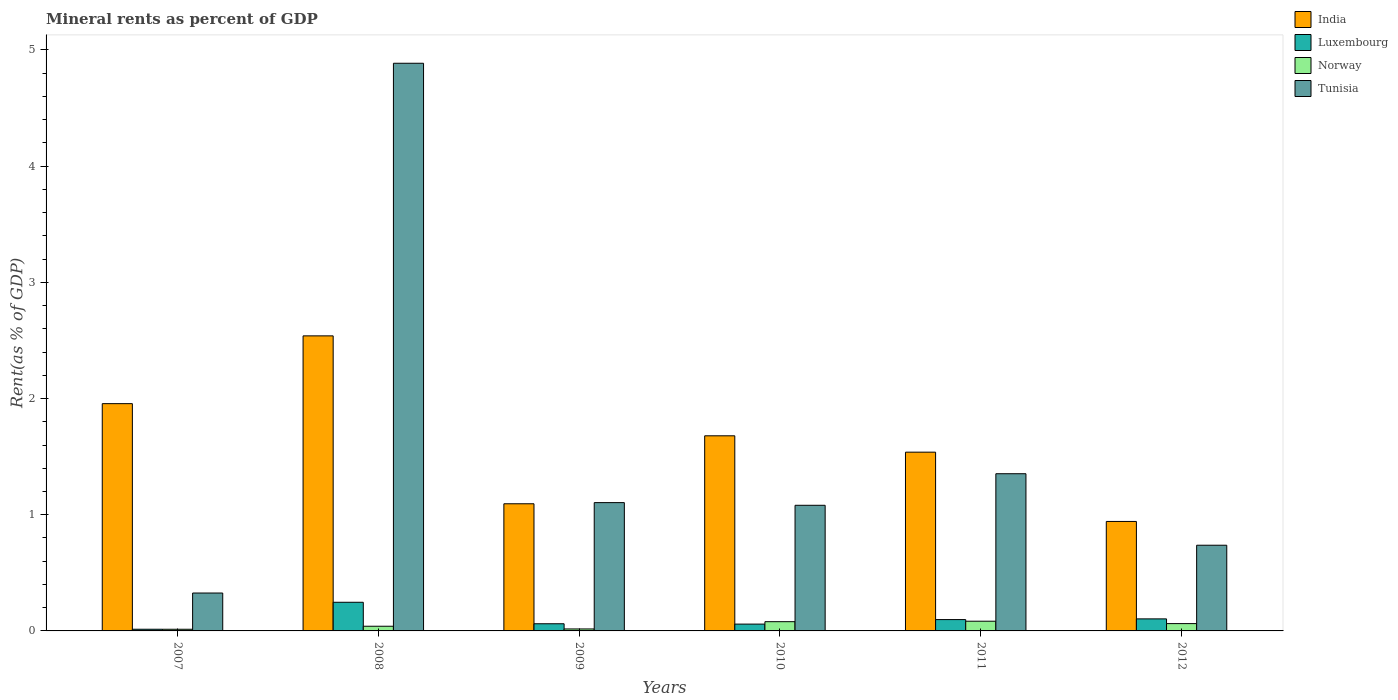How many groups of bars are there?
Provide a short and direct response. 6. Are the number of bars per tick equal to the number of legend labels?
Provide a short and direct response. Yes. Are the number of bars on each tick of the X-axis equal?
Offer a very short reply. Yes. How many bars are there on the 5th tick from the left?
Your response must be concise. 4. What is the mineral rent in India in 2009?
Ensure brevity in your answer.  1.09. Across all years, what is the maximum mineral rent in India?
Your response must be concise. 2.54. Across all years, what is the minimum mineral rent in India?
Provide a succinct answer. 0.94. In which year was the mineral rent in Luxembourg maximum?
Make the answer very short. 2008. What is the total mineral rent in Luxembourg in the graph?
Make the answer very short. 0.58. What is the difference between the mineral rent in Norway in 2007 and that in 2009?
Keep it short and to the point. -0. What is the difference between the mineral rent in Luxembourg in 2007 and the mineral rent in Norway in 2010?
Your answer should be compact. -0.07. What is the average mineral rent in Norway per year?
Provide a short and direct response. 0.05. In the year 2011, what is the difference between the mineral rent in Luxembourg and mineral rent in Tunisia?
Offer a very short reply. -1.26. In how many years, is the mineral rent in Tunisia greater than 2.8 %?
Offer a terse response. 1. What is the ratio of the mineral rent in Norway in 2008 to that in 2011?
Ensure brevity in your answer.  0.48. Is the difference between the mineral rent in Luxembourg in 2010 and 2012 greater than the difference between the mineral rent in Tunisia in 2010 and 2012?
Give a very brief answer. No. What is the difference between the highest and the second highest mineral rent in India?
Provide a short and direct response. 0.58. What is the difference between the highest and the lowest mineral rent in Luxembourg?
Offer a terse response. 0.23. In how many years, is the mineral rent in Tunisia greater than the average mineral rent in Tunisia taken over all years?
Ensure brevity in your answer.  1. Is the sum of the mineral rent in Norway in 2009 and 2012 greater than the maximum mineral rent in Luxembourg across all years?
Provide a succinct answer. No. Is it the case that in every year, the sum of the mineral rent in Tunisia and mineral rent in Norway is greater than the sum of mineral rent in India and mineral rent in Luxembourg?
Provide a succinct answer. No. What does the 1st bar from the left in 2008 represents?
Offer a terse response. India. What does the 3rd bar from the right in 2007 represents?
Give a very brief answer. Luxembourg. How many bars are there?
Provide a short and direct response. 24. What is the difference between two consecutive major ticks on the Y-axis?
Offer a terse response. 1. Are the values on the major ticks of Y-axis written in scientific E-notation?
Your answer should be very brief. No. Does the graph contain any zero values?
Provide a short and direct response. No. Does the graph contain grids?
Keep it short and to the point. No. How many legend labels are there?
Your answer should be compact. 4. What is the title of the graph?
Give a very brief answer. Mineral rents as percent of GDP. Does "American Samoa" appear as one of the legend labels in the graph?
Your response must be concise. No. What is the label or title of the Y-axis?
Keep it short and to the point. Rent(as % of GDP). What is the Rent(as % of GDP) of India in 2007?
Your response must be concise. 1.96. What is the Rent(as % of GDP) of Luxembourg in 2007?
Make the answer very short. 0.01. What is the Rent(as % of GDP) in Norway in 2007?
Keep it short and to the point. 0.01. What is the Rent(as % of GDP) in Tunisia in 2007?
Keep it short and to the point. 0.33. What is the Rent(as % of GDP) of India in 2008?
Your answer should be compact. 2.54. What is the Rent(as % of GDP) in Luxembourg in 2008?
Your answer should be compact. 0.25. What is the Rent(as % of GDP) in Norway in 2008?
Give a very brief answer. 0.04. What is the Rent(as % of GDP) of Tunisia in 2008?
Make the answer very short. 4.89. What is the Rent(as % of GDP) in India in 2009?
Provide a succinct answer. 1.09. What is the Rent(as % of GDP) of Luxembourg in 2009?
Make the answer very short. 0.06. What is the Rent(as % of GDP) in Norway in 2009?
Offer a very short reply. 0.02. What is the Rent(as % of GDP) in Tunisia in 2009?
Your answer should be very brief. 1.1. What is the Rent(as % of GDP) in India in 2010?
Your answer should be compact. 1.68. What is the Rent(as % of GDP) in Luxembourg in 2010?
Provide a short and direct response. 0.06. What is the Rent(as % of GDP) of Norway in 2010?
Your response must be concise. 0.08. What is the Rent(as % of GDP) of Tunisia in 2010?
Provide a succinct answer. 1.08. What is the Rent(as % of GDP) of India in 2011?
Your answer should be compact. 1.54. What is the Rent(as % of GDP) in Luxembourg in 2011?
Your answer should be very brief. 0.1. What is the Rent(as % of GDP) of Norway in 2011?
Offer a very short reply. 0.08. What is the Rent(as % of GDP) of Tunisia in 2011?
Your answer should be compact. 1.35. What is the Rent(as % of GDP) in India in 2012?
Keep it short and to the point. 0.94. What is the Rent(as % of GDP) of Luxembourg in 2012?
Provide a short and direct response. 0.1. What is the Rent(as % of GDP) of Norway in 2012?
Your answer should be compact. 0.06. What is the Rent(as % of GDP) in Tunisia in 2012?
Your answer should be very brief. 0.74. Across all years, what is the maximum Rent(as % of GDP) in India?
Provide a short and direct response. 2.54. Across all years, what is the maximum Rent(as % of GDP) of Luxembourg?
Give a very brief answer. 0.25. Across all years, what is the maximum Rent(as % of GDP) of Norway?
Keep it short and to the point. 0.08. Across all years, what is the maximum Rent(as % of GDP) of Tunisia?
Give a very brief answer. 4.89. Across all years, what is the minimum Rent(as % of GDP) of India?
Your answer should be very brief. 0.94. Across all years, what is the minimum Rent(as % of GDP) in Luxembourg?
Keep it short and to the point. 0.01. Across all years, what is the minimum Rent(as % of GDP) in Norway?
Offer a very short reply. 0.01. Across all years, what is the minimum Rent(as % of GDP) in Tunisia?
Keep it short and to the point. 0.33. What is the total Rent(as % of GDP) in India in the graph?
Your answer should be compact. 9.75. What is the total Rent(as % of GDP) in Luxembourg in the graph?
Your answer should be very brief. 0.58. What is the total Rent(as % of GDP) of Norway in the graph?
Provide a short and direct response. 0.3. What is the total Rent(as % of GDP) in Tunisia in the graph?
Provide a succinct answer. 9.49. What is the difference between the Rent(as % of GDP) of India in 2007 and that in 2008?
Give a very brief answer. -0.58. What is the difference between the Rent(as % of GDP) in Luxembourg in 2007 and that in 2008?
Make the answer very short. -0.23. What is the difference between the Rent(as % of GDP) in Norway in 2007 and that in 2008?
Provide a succinct answer. -0.03. What is the difference between the Rent(as % of GDP) in Tunisia in 2007 and that in 2008?
Your answer should be compact. -4.56. What is the difference between the Rent(as % of GDP) of India in 2007 and that in 2009?
Your response must be concise. 0.86. What is the difference between the Rent(as % of GDP) of Luxembourg in 2007 and that in 2009?
Make the answer very short. -0.05. What is the difference between the Rent(as % of GDP) of Norway in 2007 and that in 2009?
Ensure brevity in your answer.  -0. What is the difference between the Rent(as % of GDP) in Tunisia in 2007 and that in 2009?
Provide a succinct answer. -0.78. What is the difference between the Rent(as % of GDP) in India in 2007 and that in 2010?
Make the answer very short. 0.28. What is the difference between the Rent(as % of GDP) of Luxembourg in 2007 and that in 2010?
Your response must be concise. -0.04. What is the difference between the Rent(as % of GDP) of Norway in 2007 and that in 2010?
Make the answer very short. -0.07. What is the difference between the Rent(as % of GDP) of Tunisia in 2007 and that in 2010?
Offer a very short reply. -0.76. What is the difference between the Rent(as % of GDP) in India in 2007 and that in 2011?
Offer a very short reply. 0.42. What is the difference between the Rent(as % of GDP) of Luxembourg in 2007 and that in 2011?
Provide a succinct answer. -0.08. What is the difference between the Rent(as % of GDP) in Norway in 2007 and that in 2011?
Your answer should be very brief. -0.07. What is the difference between the Rent(as % of GDP) in Tunisia in 2007 and that in 2011?
Your answer should be very brief. -1.03. What is the difference between the Rent(as % of GDP) in India in 2007 and that in 2012?
Provide a short and direct response. 1.01. What is the difference between the Rent(as % of GDP) in Luxembourg in 2007 and that in 2012?
Your response must be concise. -0.09. What is the difference between the Rent(as % of GDP) of Norway in 2007 and that in 2012?
Your answer should be compact. -0.05. What is the difference between the Rent(as % of GDP) in Tunisia in 2007 and that in 2012?
Your response must be concise. -0.41. What is the difference between the Rent(as % of GDP) in India in 2008 and that in 2009?
Ensure brevity in your answer.  1.45. What is the difference between the Rent(as % of GDP) of Luxembourg in 2008 and that in 2009?
Provide a short and direct response. 0.18. What is the difference between the Rent(as % of GDP) of Norway in 2008 and that in 2009?
Your answer should be very brief. 0.02. What is the difference between the Rent(as % of GDP) of Tunisia in 2008 and that in 2009?
Give a very brief answer. 3.78. What is the difference between the Rent(as % of GDP) in India in 2008 and that in 2010?
Ensure brevity in your answer.  0.86. What is the difference between the Rent(as % of GDP) in Luxembourg in 2008 and that in 2010?
Your answer should be compact. 0.19. What is the difference between the Rent(as % of GDP) of Norway in 2008 and that in 2010?
Your answer should be compact. -0.04. What is the difference between the Rent(as % of GDP) in Tunisia in 2008 and that in 2010?
Provide a succinct answer. 3.8. What is the difference between the Rent(as % of GDP) in India in 2008 and that in 2011?
Offer a terse response. 1. What is the difference between the Rent(as % of GDP) in Luxembourg in 2008 and that in 2011?
Offer a terse response. 0.15. What is the difference between the Rent(as % of GDP) in Norway in 2008 and that in 2011?
Your response must be concise. -0.04. What is the difference between the Rent(as % of GDP) in Tunisia in 2008 and that in 2011?
Provide a short and direct response. 3.53. What is the difference between the Rent(as % of GDP) of India in 2008 and that in 2012?
Make the answer very short. 1.6. What is the difference between the Rent(as % of GDP) of Luxembourg in 2008 and that in 2012?
Give a very brief answer. 0.14. What is the difference between the Rent(as % of GDP) of Norway in 2008 and that in 2012?
Keep it short and to the point. -0.02. What is the difference between the Rent(as % of GDP) of Tunisia in 2008 and that in 2012?
Give a very brief answer. 4.15. What is the difference between the Rent(as % of GDP) of India in 2009 and that in 2010?
Your answer should be very brief. -0.58. What is the difference between the Rent(as % of GDP) of Luxembourg in 2009 and that in 2010?
Offer a very short reply. 0. What is the difference between the Rent(as % of GDP) of Norway in 2009 and that in 2010?
Make the answer very short. -0.06. What is the difference between the Rent(as % of GDP) in Tunisia in 2009 and that in 2010?
Offer a very short reply. 0.02. What is the difference between the Rent(as % of GDP) of India in 2009 and that in 2011?
Your response must be concise. -0.44. What is the difference between the Rent(as % of GDP) of Luxembourg in 2009 and that in 2011?
Offer a very short reply. -0.04. What is the difference between the Rent(as % of GDP) in Norway in 2009 and that in 2011?
Ensure brevity in your answer.  -0.07. What is the difference between the Rent(as % of GDP) in Tunisia in 2009 and that in 2011?
Ensure brevity in your answer.  -0.25. What is the difference between the Rent(as % of GDP) of India in 2009 and that in 2012?
Your answer should be compact. 0.15. What is the difference between the Rent(as % of GDP) in Luxembourg in 2009 and that in 2012?
Offer a very short reply. -0.04. What is the difference between the Rent(as % of GDP) in Norway in 2009 and that in 2012?
Provide a succinct answer. -0.05. What is the difference between the Rent(as % of GDP) in Tunisia in 2009 and that in 2012?
Give a very brief answer. 0.37. What is the difference between the Rent(as % of GDP) in India in 2010 and that in 2011?
Offer a very short reply. 0.14. What is the difference between the Rent(as % of GDP) in Luxembourg in 2010 and that in 2011?
Offer a terse response. -0.04. What is the difference between the Rent(as % of GDP) of Norway in 2010 and that in 2011?
Keep it short and to the point. -0. What is the difference between the Rent(as % of GDP) in Tunisia in 2010 and that in 2011?
Give a very brief answer. -0.27. What is the difference between the Rent(as % of GDP) in India in 2010 and that in 2012?
Make the answer very short. 0.74. What is the difference between the Rent(as % of GDP) of Luxembourg in 2010 and that in 2012?
Provide a succinct answer. -0.04. What is the difference between the Rent(as % of GDP) of Norway in 2010 and that in 2012?
Make the answer very short. 0.02. What is the difference between the Rent(as % of GDP) in Tunisia in 2010 and that in 2012?
Ensure brevity in your answer.  0.34. What is the difference between the Rent(as % of GDP) in India in 2011 and that in 2012?
Provide a short and direct response. 0.6. What is the difference between the Rent(as % of GDP) in Luxembourg in 2011 and that in 2012?
Provide a succinct answer. -0.01. What is the difference between the Rent(as % of GDP) of Norway in 2011 and that in 2012?
Make the answer very short. 0.02. What is the difference between the Rent(as % of GDP) in Tunisia in 2011 and that in 2012?
Your answer should be very brief. 0.62. What is the difference between the Rent(as % of GDP) in India in 2007 and the Rent(as % of GDP) in Luxembourg in 2008?
Your answer should be compact. 1.71. What is the difference between the Rent(as % of GDP) of India in 2007 and the Rent(as % of GDP) of Norway in 2008?
Your response must be concise. 1.92. What is the difference between the Rent(as % of GDP) of India in 2007 and the Rent(as % of GDP) of Tunisia in 2008?
Ensure brevity in your answer.  -2.93. What is the difference between the Rent(as % of GDP) in Luxembourg in 2007 and the Rent(as % of GDP) in Norway in 2008?
Offer a terse response. -0.03. What is the difference between the Rent(as % of GDP) in Luxembourg in 2007 and the Rent(as % of GDP) in Tunisia in 2008?
Offer a very short reply. -4.87. What is the difference between the Rent(as % of GDP) of Norway in 2007 and the Rent(as % of GDP) of Tunisia in 2008?
Provide a succinct answer. -4.87. What is the difference between the Rent(as % of GDP) of India in 2007 and the Rent(as % of GDP) of Luxembourg in 2009?
Ensure brevity in your answer.  1.89. What is the difference between the Rent(as % of GDP) of India in 2007 and the Rent(as % of GDP) of Norway in 2009?
Keep it short and to the point. 1.94. What is the difference between the Rent(as % of GDP) in India in 2007 and the Rent(as % of GDP) in Tunisia in 2009?
Your response must be concise. 0.85. What is the difference between the Rent(as % of GDP) in Luxembourg in 2007 and the Rent(as % of GDP) in Norway in 2009?
Give a very brief answer. -0. What is the difference between the Rent(as % of GDP) in Luxembourg in 2007 and the Rent(as % of GDP) in Tunisia in 2009?
Provide a succinct answer. -1.09. What is the difference between the Rent(as % of GDP) in Norway in 2007 and the Rent(as % of GDP) in Tunisia in 2009?
Give a very brief answer. -1.09. What is the difference between the Rent(as % of GDP) in India in 2007 and the Rent(as % of GDP) in Luxembourg in 2010?
Your answer should be compact. 1.9. What is the difference between the Rent(as % of GDP) of India in 2007 and the Rent(as % of GDP) of Norway in 2010?
Your response must be concise. 1.88. What is the difference between the Rent(as % of GDP) in India in 2007 and the Rent(as % of GDP) in Tunisia in 2010?
Provide a short and direct response. 0.87. What is the difference between the Rent(as % of GDP) of Luxembourg in 2007 and the Rent(as % of GDP) of Norway in 2010?
Offer a terse response. -0.07. What is the difference between the Rent(as % of GDP) in Luxembourg in 2007 and the Rent(as % of GDP) in Tunisia in 2010?
Keep it short and to the point. -1.07. What is the difference between the Rent(as % of GDP) in Norway in 2007 and the Rent(as % of GDP) in Tunisia in 2010?
Your response must be concise. -1.07. What is the difference between the Rent(as % of GDP) of India in 2007 and the Rent(as % of GDP) of Luxembourg in 2011?
Your response must be concise. 1.86. What is the difference between the Rent(as % of GDP) of India in 2007 and the Rent(as % of GDP) of Norway in 2011?
Provide a short and direct response. 1.87. What is the difference between the Rent(as % of GDP) in India in 2007 and the Rent(as % of GDP) in Tunisia in 2011?
Give a very brief answer. 0.6. What is the difference between the Rent(as % of GDP) in Luxembourg in 2007 and the Rent(as % of GDP) in Norway in 2011?
Ensure brevity in your answer.  -0.07. What is the difference between the Rent(as % of GDP) in Luxembourg in 2007 and the Rent(as % of GDP) in Tunisia in 2011?
Give a very brief answer. -1.34. What is the difference between the Rent(as % of GDP) in Norway in 2007 and the Rent(as % of GDP) in Tunisia in 2011?
Offer a terse response. -1.34. What is the difference between the Rent(as % of GDP) in India in 2007 and the Rent(as % of GDP) in Luxembourg in 2012?
Keep it short and to the point. 1.85. What is the difference between the Rent(as % of GDP) in India in 2007 and the Rent(as % of GDP) in Norway in 2012?
Offer a very short reply. 1.89. What is the difference between the Rent(as % of GDP) of India in 2007 and the Rent(as % of GDP) of Tunisia in 2012?
Your answer should be compact. 1.22. What is the difference between the Rent(as % of GDP) of Luxembourg in 2007 and the Rent(as % of GDP) of Norway in 2012?
Offer a very short reply. -0.05. What is the difference between the Rent(as % of GDP) in Luxembourg in 2007 and the Rent(as % of GDP) in Tunisia in 2012?
Give a very brief answer. -0.72. What is the difference between the Rent(as % of GDP) of Norway in 2007 and the Rent(as % of GDP) of Tunisia in 2012?
Your answer should be compact. -0.72. What is the difference between the Rent(as % of GDP) of India in 2008 and the Rent(as % of GDP) of Luxembourg in 2009?
Your answer should be very brief. 2.48. What is the difference between the Rent(as % of GDP) in India in 2008 and the Rent(as % of GDP) in Norway in 2009?
Offer a terse response. 2.52. What is the difference between the Rent(as % of GDP) of India in 2008 and the Rent(as % of GDP) of Tunisia in 2009?
Offer a very short reply. 1.44. What is the difference between the Rent(as % of GDP) in Luxembourg in 2008 and the Rent(as % of GDP) in Norway in 2009?
Keep it short and to the point. 0.23. What is the difference between the Rent(as % of GDP) of Luxembourg in 2008 and the Rent(as % of GDP) of Tunisia in 2009?
Your response must be concise. -0.86. What is the difference between the Rent(as % of GDP) in Norway in 2008 and the Rent(as % of GDP) in Tunisia in 2009?
Provide a succinct answer. -1.06. What is the difference between the Rent(as % of GDP) in India in 2008 and the Rent(as % of GDP) in Luxembourg in 2010?
Provide a succinct answer. 2.48. What is the difference between the Rent(as % of GDP) of India in 2008 and the Rent(as % of GDP) of Norway in 2010?
Make the answer very short. 2.46. What is the difference between the Rent(as % of GDP) in India in 2008 and the Rent(as % of GDP) in Tunisia in 2010?
Your answer should be very brief. 1.46. What is the difference between the Rent(as % of GDP) of Luxembourg in 2008 and the Rent(as % of GDP) of Norway in 2010?
Offer a very short reply. 0.17. What is the difference between the Rent(as % of GDP) of Luxembourg in 2008 and the Rent(as % of GDP) of Tunisia in 2010?
Keep it short and to the point. -0.83. What is the difference between the Rent(as % of GDP) of Norway in 2008 and the Rent(as % of GDP) of Tunisia in 2010?
Keep it short and to the point. -1.04. What is the difference between the Rent(as % of GDP) of India in 2008 and the Rent(as % of GDP) of Luxembourg in 2011?
Your answer should be very brief. 2.44. What is the difference between the Rent(as % of GDP) of India in 2008 and the Rent(as % of GDP) of Norway in 2011?
Provide a succinct answer. 2.46. What is the difference between the Rent(as % of GDP) in India in 2008 and the Rent(as % of GDP) in Tunisia in 2011?
Ensure brevity in your answer.  1.19. What is the difference between the Rent(as % of GDP) of Luxembourg in 2008 and the Rent(as % of GDP) of Norway in 2011?
Provide a succinct answer. 0.16. What is the difference between the Rent(as % of GDP) in Luxembourg in 2008 and the Rent(as % of GDP) in Tunisia in 2011?
Your response must be concise. -1.11. What is the difference between the Rent(as % of GDP) in Norway in 2008 and the Rent(as % of GDP) in Tunisia in 2011?
Keep it short and to the point. -1.31. What is the difference between the Rent(as % of GDP) of India in 2008 and the Rent(as % of GDP) of Luxembourg in 2012?
Provide a short and direct response. 2.44. What is the difference between the Rent(as % of GDP) in India in 2008 and the Rent(as % of GDP) in Norway in 2012?
Provide a short and direct response. 2.48. What is the difference between the Rent(as % of GDP) in India in 2008 and the Rent(as % of GDP) in Tunisia in 2012?
Make the answer very short. 1.8. What is the difference between the Rent(as % of GDP) in Luxembourg in 2008 and the Rent(as % of GDP) in Norway in 2012?
Offer a very short reply. 0.18. What is the difference between the Rent(as % of GDP) of Luxembourg in 2008 and the Rent(as % of GDP) of Tunisia in 2012?
Keep it short and to the point. -0.49. What is the difference between the Rent(as % of GDP) in Norway in 2008 and the Rent(as % of GDP) in Tunisia in 2012?
Give a very brief answer. -0.7. What is the difference between the Rent(as % of GDP) of India in 2009 and the Rent(as % of GDP) of Luxembourg in 2010?
Make the answer very short. 1.04. What is the difference between the Rent(as % of GDP) of India in 2009 and the Rent(as % of GDP) of Norway in 2010?
Your response must be concise. 1.01. What is the difference between the Rent(as % of GDP) of India in 2009 and the Rent(as % of GDP) of Tunisia in 2010?
Your answer should be very brief. 0.01. What is the difference between the Rent(as % of GDP) of Luxembourg in 2009 and the Rent(as % of GDP) of Norway in 2010?
Your answer should be compact. -0.02. What is the difference between the Rent(as % of GDP) of Luxembourg in 2009 and the Rent(as % of GDP) of Tunisia in 2010?
Make the answer very short. -1.02. What is the difference between the Rent(as % of GDP) of Norway in 2009 and the Rent(as % of GDP) of Tunisia in 2010?
Offer a terse response. -1.06. What is the difference between the Rent(as % of GDP) of India in 2009 and the Rent(as % of GDP) of Luxembourg in 2011?
Provide a short and direct response. 1. What is the difference between the Rent(as % of GDP) in India in 2009 and the Rent(as % of GDP) in Norway in 2011?
Give a very brief answer. 1.01. What is the difference between the Rent(as % of GDP) of India in 2009 and the Rent(as % of GDP) of Tunisia in 2011?
Offer a very short reply. -0.26. What is the difference between the Rent(as % of GDP) in Luxembourg in 2009 and the Rent(as % of GDP) in Norway in 2011?
Offer a very short reply. -0.02. What is the difference between the Rent(as % of GDP) in Luxembourg in 2009 and the Rent(as % of GDP) in Tunisia in 2011?
Ensure brevity in your answer.  -1.29. What is the difference between the Rent(as % of GDP) in Norway in 2009 and the Rent(as % of GDP) in Tunisia in 2011?
Your answer should be compact. -1.34. What is the difference between the Rent(as % of GDP) in India in 2009 and the Rent(as % of GDP) in Norway in 2012?
Give a very brief answer. 1.03. What is the difference between the Rent(as % of GDP) of India in 2009 and the Rent(as % of GDP) of Tunisia in 2012?
Provide a succinct answer. 0.36. What is the difference between the Rent(as % of GDP) in Luxembourg in 2009 and the Rent(as % of GDP) in Norway in 2012?
Ensure brevity in your answer.  -0. What is the difference between the Rent(as % of GDP) in Luxembourg in 2009 and the Rent(as % of GDP) in Tunisia in 2012?
Give a very brief answer. -0.68. What is the difference between the Rent(as % of GDP) in Norway in 2009 and the Rent(as % of GDP) in Tunisia in 2012?
Your answer should be compact. -0.72. What is the difference between the Rent(as % of GDP) in India in 2010 and the Rent(as % of GDP) in Luxembourg in 2011?
Keep it short and to the point. 1.58. What is the difference between the Rent(as % of GDP) of India in 2010 and the Rent(as % of GDP) of Norway in 2011?
Provide a short and direct response. 1.6. What is the difference between the Rent(as % of GDP) of India in 2010 and the Rent(as % of GDP) of Tunisia in 2011?
Give a very brief answer. 0.33. What is the difference between the Rent(as % of GDP) of Luxembourg in 2010 and the Rent(as % of GDP) of Norway in 2011?
Make the answer very short. -0.02. What is the difference between the Rent(as % of GDP) in Luxembourg in 2010 and the Rent(as % of GDP) in Tunisia in 2011?
Keep it short and to the point. -1.29. What is the difference between the Rent(as % of GDP) of Norway in 2010 and the Rent(as % of GDP) of Tunisia in 2011?
Ensure brevity in your answer.  -1.27. What is the difference between the Rent(as % of GDP) of India in 2010 and the Rent(as % of GDP) of Luxembourg in 2012?
Your response must be concise. 1.58. What is the difference between the Rent(as % of GDP) of India in 2010 and the Rent(as % of GDP) of Norway in 2012?
Give a very brief answer. 1.62. What is the difference between the Rent(as % of GDP) of India in 2010 and the Rent(as % of GDP) of Tunisia in 2012?
Your answer should be very brief. 0.94. What is the difference between the Rent(as % of GDP) of Luxembourg in 2010 and the Rent(as % of GDP) of Norway in 2012?
Provide a short and direct response. -0. What is the difference between the Rent(as % of GDP) in Luxembourg in 2010 and the Rent(as % of GDP) in Tunisia in 2012?
Your response must be concise. -0.68. What is the difference between the Rent(as % of GDP) in Norway in 2010 and the Rent(as % of GDP) in Tunisia in 2012?
Provide a succinct answer. -0.66. What is the difference between the Rent(as % of GDP) of India in 2011 and the Rent(as % of GDP) of Luxembourg in 2012?
Keep it short and to the point. 1.43. What is the difference between the Rent(as % of GDP) of India in 2011 and the Rent(as % of GDP) of Norway in 2012?
Your response must be concise. 1.48. What is the difference between the Rent(as % of GDP) in India in 2011 and the Rent(as % of GDP) in Tunisia in 2012?
Offer a terse response. 0.8. What is the difference between the Rent(as % of GDP) in Luxembourg in 2011 and the Rent(as % of GDP) in Norway in 2012?
Make the answer very short. 0.03. What is the difference between the Rent(as % of GDP) in Luxembourg in 2011 and the Rent(as % of GDP) in Tunisia in 2012?
Give a very brief answer. -0.64. What is the difference between the Rent(as % of GDP) of Norway in 2011 and the Rent(as % of GDP) of Tunisia in 2012?
Provide a succinct answer. -0.65. What is the average Rent(as % of GDP) in India per year?
Keep it short and to the point. 1.62. What is the average Rent(as % of GDP) of Luxembourg per year?
Your answer should be compact. 0.1. What is the average Rent(as % of GDP) of Norway per year?
Make the answer very short. 0.05. What is the average Rent(as % of GDP) in Tunisia per year?
Offer a terse response. 1.58. In the year 2007, what is the difference between the Rent(as % of GDP) of India and Rent(as % of GDP) of Luxembourg?
Give a very brief answer. 1.94. In the year 2007, what is the difference between the Rent(as % of GDP) of India and Rent(as % of GDP) of Norway?
Provide a short and direct response. 1.94. In the year 2007, what is the difference between the Rent(as % of GDP) of India and Rent(as % of GDP) of Tunisia?
Offer a terse response. 1.63. In the year 2007, what is the difference between the Rent(as % of GDP) of Luxembourg and Rent(as % of GDP) of Tunisia?
Offer a very short reply. -0.31. In the year 2007, what is the difference between the Rent(as % of GDP) in Norway and Rent(as % of GDP) in Tunisia?
Provide a succinct answer. -0.31. In the year 2008, what is the difference between the Rent(as % of GDP) of India and Rent(as % of GDP) of Luxembourg?
Ensure brevity in your answer.  2.29. In the year 2008, what is the difference between the Rent(as % of GDP) in India and Rent(as % of GDP) in Norway?
Give a very brief answer. 2.5. In the year 2008, what is the difference between the Rent(as % of GDP) in India and Rent(as % of GDP) in Tunisia?
Offer a terse response. -2.35. In the year 2008, what is the difference between the Rent(as % of GDP) of Luxembourg and Rent(as % of GDP) of Norway?
Offer a terse response. 0.21. In the year 2008, what is the difference between the Rent(as % of GDP) of Luxembourg and Rent(as % of GDP) of Tunisia?
Ensure brevity in your answer.  -4.64. In the year 2008, what is the difference between the Rent(as % of GDP) in Norway and Rent(as % of GDP) in Tunisia?
Make the answer very short. -4.85. In the year 2009, what is the difference between the Rent(as % of GDP) of India and Rent(as % of GDP) of Luxembourg?
Offer a terse response. 1.03. In the year 2009, what is the difference between the Rent(as % of GDP) in India and Rent(as % of GDP) in Norway?
Offer a very short reply. 1.08. In the year 2009, what is the difference between the Rent(as % of GDP) of India and Rent(as % of GDP) of Tunisia?
Offer a terse response. -0.01. In the year 2009, what is the difference between the Rent(as % of GDP) of Luxembourg and Rent(as % of GDP) of Norway?
Offer a terse response. 0.04. In the year 2009, what is the difference between the Rent(as % of GDP) of Luxembourg and Rent(as % of GDP) of Tunisia?
Give a very brief answer. -1.04. In the year 2009, what is the difference between the Rent(as % of GDP) of Norway and Rent(as % of GDP) of Tunisia?
Provide a succinct answer. -1.09. In the year 2010, what is the difference between the Rent(as % of GDP) of India and Rent(as % of GDP) of Luxembourg?
Make the answer very short. 1.62. In the year 2010, what is the difference between the Rent(as % of GDP) in India and Rent(as % of GDP) in Norway?
Keep it short and to the point. 1.6. In the year 2010, what is the difference between the Rent(as % of GDP) in India and Rent(as % of GDP) in Tunisia?
Ensure brevity in your answer.  0.6. In the year 2010, what is the difference between the Rent(as % of GDP) in Luxembourg and Rent(as % of GDP) in Norway?
Provide a succinct answer. -0.02. In the year 2010, what is the difference between the Rent(as % of GDP) of Luxembourg and Rent(as % of GDP) of Tunisia?
Your answer should be compact. -1.02. In the year 2010, what is the difference between the Rent(as % of GDP) of Norway and Rent(as % of GDP) of Tunisia?
Offer a terse response. -1. In the year 2011, what is the difference between the Rent(as % of GDP) of India and Rent(as % of GDP) of Luxembourg?
Your response must be concise. 1.44. In the year 2011, what is the difference between the Rent(as % of GDP) of India and Rent(as % of GDP) of Norway?
Your answer should be very brief. 1.45. In the year 2011, what is the difference between the Rent(as % of GDP) in India and Rent(as % of GDP) in Tunisia?
Provide a succinct answer. 0.19. In the year 2011, what is the difference between the Rent(as % of GDP) in Luxembourg and Rent(as % of GDP) in Norway?
Your response must be concise. 0.01. In the year 2011, what is the difference between the Rent(as % of GDP) in Luxembourg and Rent(as % of GDP) in Tunisia?
Make the answer very short. -1.26. In the year 2011, what is the difference between the Rent(as % of GDP) in Norway and Rent(as % of GDP) in Tunisia?
Provide a short and direct response. -1.27. In the year 2012, what is the difference between the Rent(as % of GDP) of India and Rent(as % of GDP) of Luxembourg?
Ensure brevity in your answer.  0.84. In the year 2012, what is the difference between the Rent(as % of GDP) in India and Rent(as % of GDP) in Norway?
Your response must be concise. 0.88. In the year 2012, what is the difference between the Rent(as % of GDP) of India and Rent(as % of GDP) of Tunisia?
Keep it short and to the point. 0.2. In the year 2012, what is the difference between the Rent(as % of GDP) in Luxembourg and Rent(as % of GDP) in Norway?
Your answer should be very brief. 0.04. In the year 2012, what is the difference between the Rent(as % of GDP) of Luxembourg and Rent(as % of GDP) of Tunisia?
Offer a terse response. -0.63. In the year 2012, what is the difference between the Rent(as % of GDP) in Norway and Rent(as % of GDP) in Tunisia?
Ensure brevity in your answer.  -0.67. What is the ratio of the Rent(as % of GDP) of India in 2007 to that in 2008?
Provide a short and direct response. 0.77. What is the ratio of the Rent(as % of GDP) in Luxembourg in 2007 to that in 2008?
Make the answer very short. 0.06. What is the ratio of the Rent(as % of GDP) in Norway in 2007 to that in 2008?
Your answer should be compact. 0.36. What is the ratio of the Rent(as % of GDP) of Tunisia in 2007 to that in 2008?
Make the answer very short. 0.07. What is the ratio of the Rent(as % of GDP) of India in 2007 to that in 2009?
Your answer should be very brief. 1.79. What is the ratio of the Rent(as % of GDP) in Luxembourg in 2007 to that in 2009?
Ensure brevity in your answer.  0.23. What is the ratio of the Rent(as % of GDP) in Norway in 2007 to that in 2009?
Your response must be concise. 0.85. What is the ratio of the Rent(as % of GDP) in Tunisia in 2007 to that in 2009?
Ensure brevity in your answer.  0.3. What is the ratio of the Rent(as % of GDP) of India in 2007 to that in 2010?
Your answer should be very brief. 1.16. What is the ratio of the Rent(as % of GDP) of Luxembourg in 2007 to that in 2010?
Provide a succinct answer. 0.25. What is the ratio of the Rent(as % of GDP) in Norway in 2007 to that in 2010?
Provide a succinct answer. 0.18. What is the ratio of the Rent(as % of GDP) in Tunisia in 2007 to that in 2010?
Offer a very short reply. 0.3. What is the ratio of the Rent(as % of GDP) in India in 2007 to that in 2011?
Offer a terse response. 1.27. What is the ratio of the Rent(as % of GDP) in Luxembourg in 2007 to that in 2011?
Provide a succinct answer. 0.15. What is the ratio of the Rent(as % of GDP) of Norway in 2007 to that in 2011?
Your response must be concise. 0.17. What is the ratio of the Rent(as % of GDP) of Tunisia in 2007 to that in 2011?
Make the answer very short. 0.24. What is the ratio of the Rent(as % of GDP) of India in 2007 to that in 2012?
Your answer should be compact. 2.08. What is the ratio of the Rent(as % of GDP) in Luxembourg in 2007 to that in 2012?
Offer a terse response. 0.14. What is the ratio of the Rent(as % of GDP) in Norway in 2007 to that in 2012?
Give a very brief answer. 0.23. What is the ratio of the Rent(as % of GDP) of Tunisia in 2007 to that in 2012?
Offer a very short reply. 0.44. What is the ratio of the Rent(as % of GDP) of India in 2008 to that in 2009?
Make the answer very short. 2.32. What is the ratio of the Rent(as % of GDP) of Luxembourg in 2008 to that in 2009?
Make the answer very short. 4. What is the ratio of the Rent(as % of GDP) of Norway in 2008 to that in 2009?
Offer a terse response. 2.38. What is the ratio of the Rent(as % of GDP) in Tunisia in 2008 to that in 2009?
Keep it short and to the point. 4.42. What is the ratio of the Rent(as % of GDP) of India in 2008 to that in 2010?
Provide a succinct answer. 1.51. What is the ratio of the Rent(as % of GDP) of Luxembourg in 2008 to that in 2010?
Give a very brief answer. 4.2. What is the ratio of the Rent(as % of GDP) of Norway in 2008 to that in 2010?
Your answer should be compact. 0.51. What is the ratio of the Rent(as % of GDP) of Tunisia in 2008 to that in 2010?
Offer a very short reply. 4.52. What is the ratio of the Rent(as % of GDP) in India in 2008 to that in 2011?
Provide a succinct answer. 1.65. What is the ratio of the Rent(as % of GDP) in Luxembourg in 2008 to that in 2011?
Offer a terse response. 2.53. What is the ratio of the Rent(as % of GDP) of Norway in 2008 to that in 2011?
Ensure brevity in your answer.  0.48. What is the ratio of the Rent(as % of GDP) in Tunisia in 2008 to that in 2011?
Provide a succinct answer. 3.61. What is the ratio of the Rent(as % of GDP) in India in 2008 to that in 2012?
Offer a very short reply. 2.7. What is the ratio of the Rent(as % of GDP) of Luxembourg in 2008 to that in 2012?
Your answer should be compact. 2.38. What is the ratio of the Rent(as % of GDP) in Norway in 2008 to that in 2012?
Ensure brevity in your answer.  0.64. What is the ratio of the Rent(as % of GDP) of Tunisia in 2008 to that in 2012?
Your response must be concise. 6.62. What is the ratio of the Rent(as % of GDP) in India in 2009 to that in 2010?
Keep it short and to the point. 0.65. What is the ratio of the Rent(as % of GDP) of Luxembourg in 2009 to that in 2010?
Ensure brevity in your answer.  1.05. What is the ratio of the Rent(as % of GDP) of Norway in 2009 to that in 2010?
Your answer should be compact. 0.21. What is the ratio of the Rent(as % of GDP) of Tunisia in 2009 to that in 2010?
Offer a very short reply. 1.02. What is the ratio of the Rent(as % of GDP) in India in 2009 to that in 2011?
Make the answer very short. 0.71. What is the ratio of the Rent(as % of GDP) of Luxembourg in 2009 to that in 2011?
Give a very brief answer. 0.63. What is the ratio of the Rent(as % of GDP) in Norway in 2009 to that in 2011?
Give a very brief answer. 0.2. What is the ratio of the Rent(as % of GDP) in Tunisia in 2009 to that in 2011?
Keep it short and to the point. 0.82. What is the ratio of the Rent(as % of GDP) in India in 2009 to that in 2012?
Provide a short and direct response. 1.16. What is the ratio of the Rent(as % of GDP) of Luxembourg in 2009 to that in 2012?
Your answer should be very brief. 0.6. What is the ratio of the Rent(as % of GDP) of Norway in 2009 to that in 2012?
Your answer should be compact. 0.27. What is the ratio of the Rent(as % of GDP) in Tunisia in 2009 to that in 2012?
Keep it short and to the point. 1.5. What is the ratio of the Rent(as % of GDP) in India in 2010 to that in 2011?
Make the answer very short. 1.09. What is the ratio of the Rent(as % of GDP) in Luxembourg in 2010 to that in 2011?
Make the answer very short. 0.6. What is the ratio of the Rent(as % of GDP) of Norway in 2010 to that in 2011?
Provide a succinct answer. 0.95. What is the ratio of the Rent(as % of GDP) in Tunisia in 2010 to that in 2011?
Provide a short and direct response. 0.8. What is the ratio of the Rent(as % of GDP) in India in 2010 to that in 2012?
Ensure brevity in your answer.  1.78. What is the ratio of the Rent(as % of GDP) in Luxembourg in 2010 to that in 2012?
Provide a succinct answer. 0.57. What is the ratio of the Rent(as % of GDP) of Norway in 2010 to that in 2012?
Provide a succinct answer. 1.26. What is the ratio of the Rent(as % of GDP) of Tunisia in 2010 to that in 2012?
Ensure brevity in your answer.  1.47. What is the ratio of the Rent(as % of GDP) of India in 2011 to that in 2012?
Your answer should be compact. 1.63. What is the ratio of the Rent(as % of GDP) in Luxembourg in 2011 to that in 2012?
Provide a succinct answer. 0.94. What is the ratio of the Rent(as % of GDP) of Norway in 2011 to that in 2012?
Provide a succinct answer. 1.33. What is the ratio of the Rent(as % of GDP) in Tunisia in 2011 to that in 2012?
Keep it short and to the point. 1.83. What is the difference between the highest and the second highest Rent(as % of GDP) of India?
Offer a very short reply. 0.58. What is the difference between the highest and the second highest Rent(as % of GDP) of Luxembourg?
Your answer should be compact. 0.14. What is the difference between the highest and the second highest Rent(as % of GDP) of Norway?
Your response must be concise. 0. What is the difference between the highest and the second highest Rent(as % of GDP) in Tunisia?
Your answer should be very brief. 3.53. What is the difference between the highest and the lowest Rent(as % of GDP) of India?
Ensure brevity in your answer.  1.6. What is the difference between the highest and the lowest Rent(as % of GDP) in Luxembourg?
Ensure brevity in your answer.  0.23. What is the difference between the highest and the lowest Rent(as % of GDP) of Norway?
Your answer should be compact. 0.07. What is the difference between the highest and the lowest Rent(as % of GDP) of Tunisia?
Your answer should be compact. 4.56. 